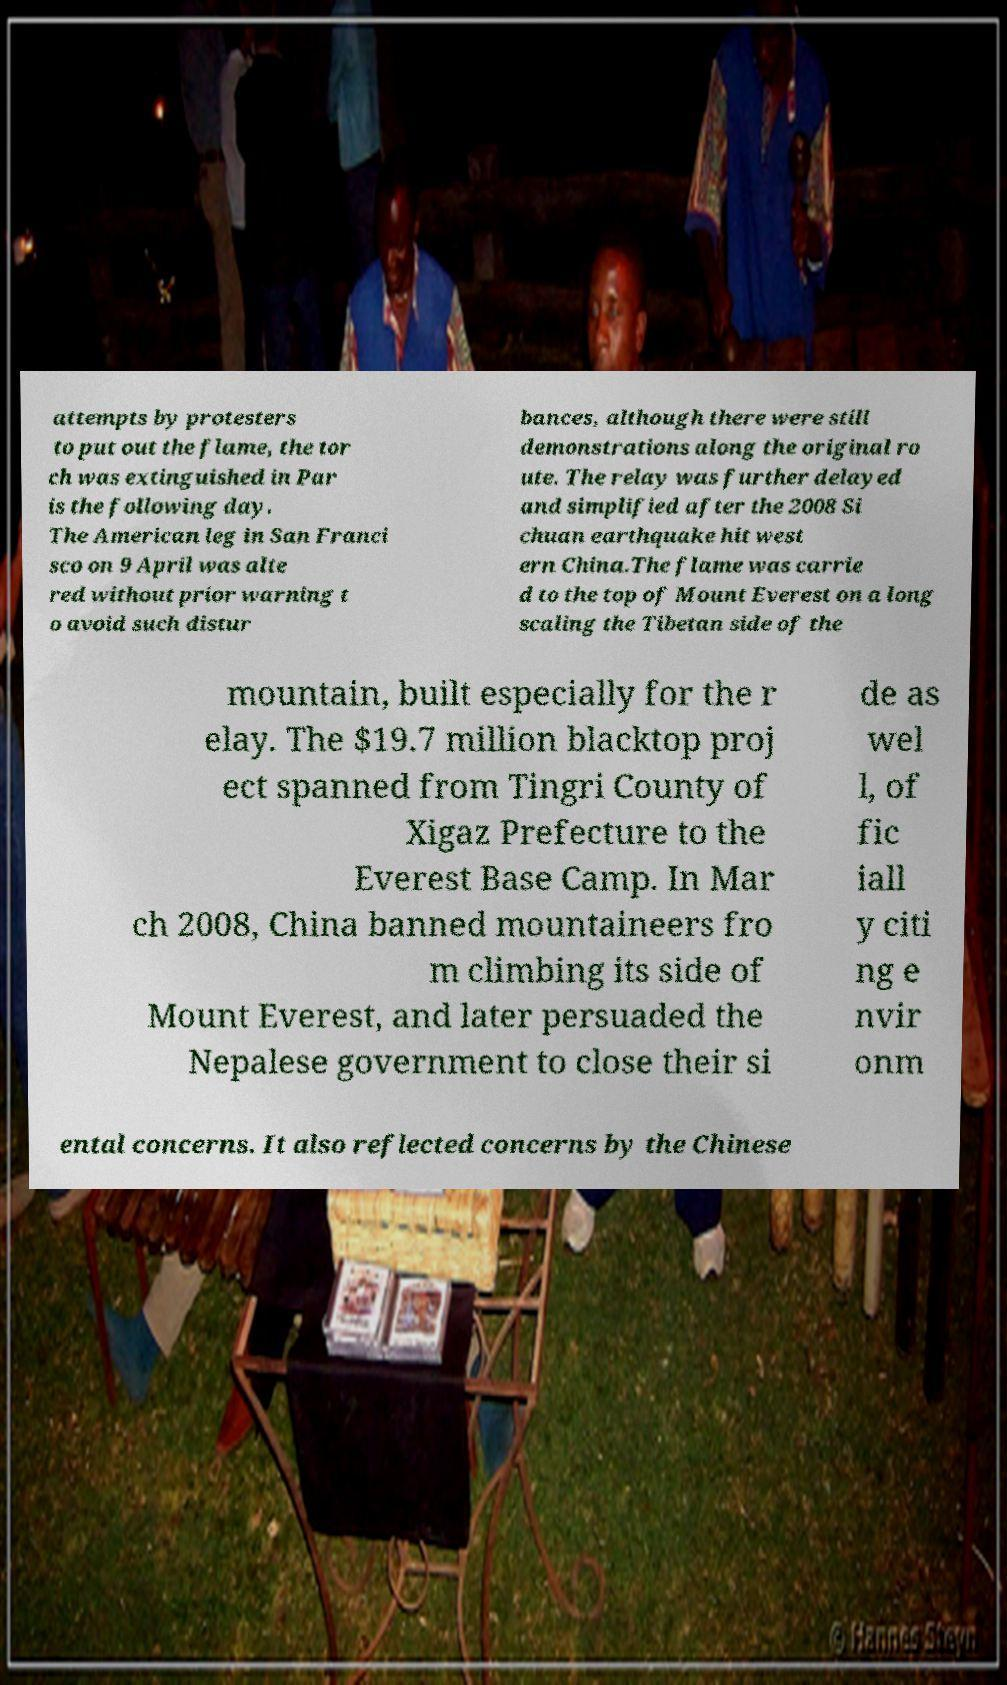Please identify and transcribe the text found in this image. attempts by protesters to put out the flame, the tor ch was extinguished in Par is the following day. The American leg in San Franci sco on 9 April was alte red without prior warning t o avoid such distur bances, although there were still demonstrations along the original ro ute. The relay was further delayed and simplified after the 2008 Si chuan earthquake hit west ern China.The flame was carrie d to the top of Mount Everest on a long scaling the Tibetan side of the mountain, built especially for the r elay. The $19.7 million blacktop proj ect spanned from Tingri County of Xigaz Prefecture to the Everest Base Camp. In Mar ch 2008, China banned mountaineers fro m climbing its side of Mount Everest, and later persuaded the Nepalese government to close their si de as wel l, of fic iall y citi ng e nvir onm ental concerns. It also reflected concerns by the Chinese 